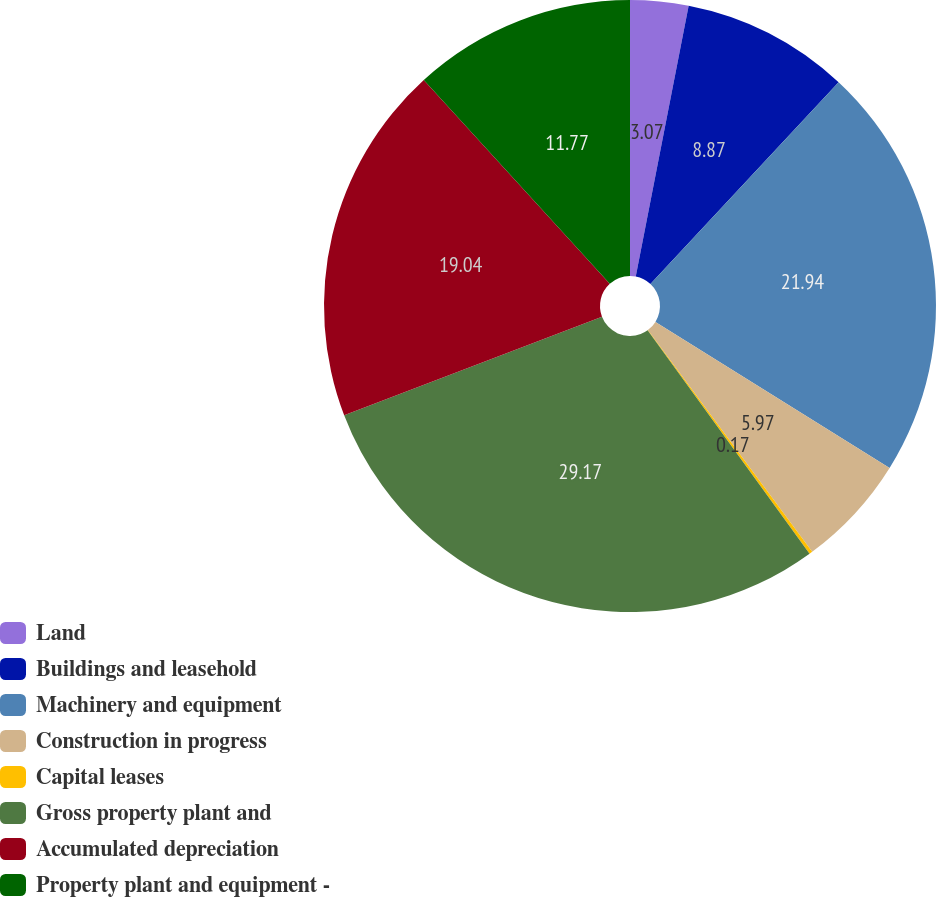Convert chart to OTSL. <chart><loc_0><loc_0><loc_500><loc_500><pie_chart><fcel>Land<fcel>Buildings and leasehold<fcel>Machinery and equipment<fcel>Construction in progress<fcel>Capital leases<fcel>Gross property plant and<fcel>Accumulated depreciation<fcel>Property plant and equipment -<nl><fcel>3.07%<fcel>8.87%<fcel>21.94%<fcel>5.97%<fcel>0.17%<fcel>29.17%<fcel>19.04%<fcel>11.77%<nl></chart> 